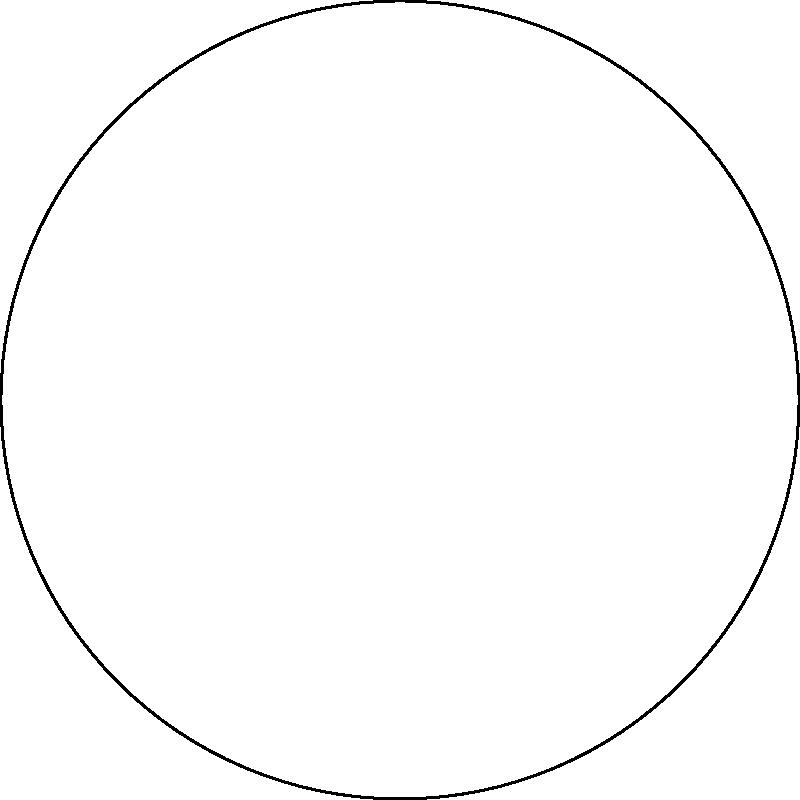Your circular barbecue grill has 6 equally spaced burners around its edge, labeled A through F as shown in the diagram. If you rotate the grill by one position clockwise, burner A will move to the position currently occupied by F. How many unique arrangements of the burners can you create by rotating the grill? (Consider two arrangements the same if they can be obtained from each other by rotation.) Let's approach this step-by-step:

1) First, we need to understand what rotational symmetry means in this context. It means that if we rotate the grill by a certain amount, it looks the same as before.

2) In this case, we have 6 burners equally spaced around the circle. This means we can rotate the grill by 360°/6 = 60° and it will look the same, just with the burners in different positions.

3) Now, let's consider the possible rotations:
   - 0° rotation (original position)
   - 60° rotation (A moves to F's position)
   - 120° rotation (A moves to E's position)
   - 180° rotation (A moves to D's position)
   - 240° rotation (A moves to C's position)
   - 300° rotation (A moves to B's position)

4) After a 360° rotation, we're back to the original position.

5) Each of these rotations produces a unique arrangement of the burners.

6) Any further rotation will produce an arrangement that's identical to one of these.

Therefore, there are 6 unique arrangements that can be created by rotating the grill.
Answer: 6 